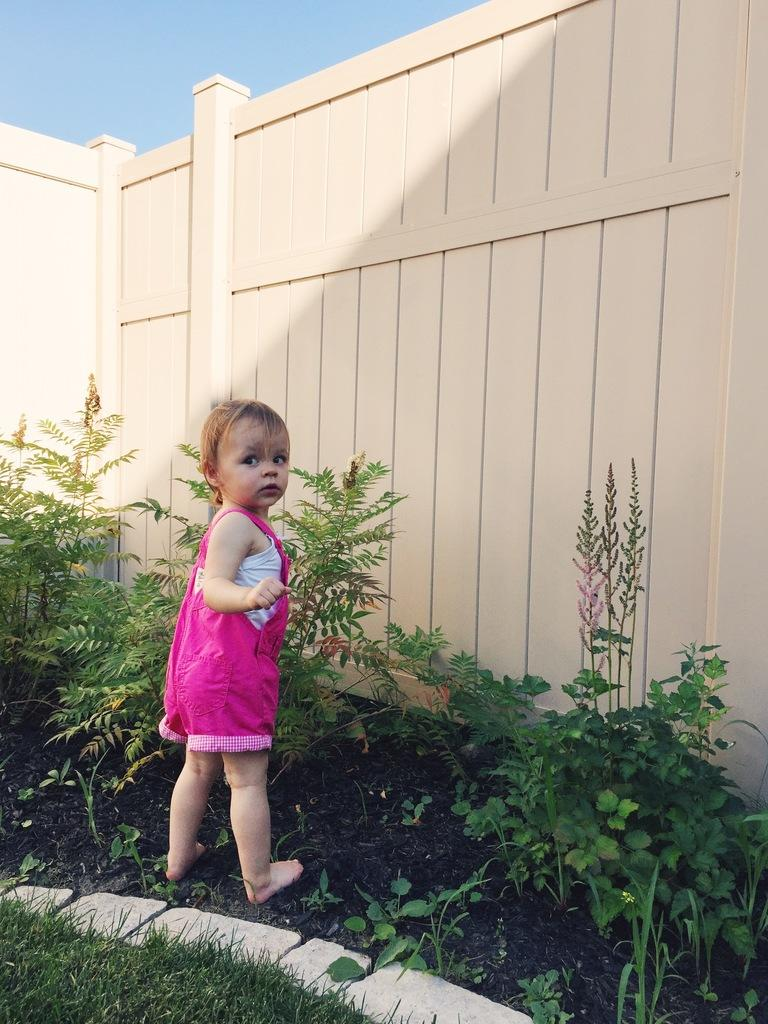What is the main subject of the image? There is a baby in the image. What is the baby wearing? The baby is wearing a pink dress. Where is the baby standing? The baby is standing on grass land. What can be seen in front of the baby? There are plants in front of the baby. What is located behind the plants? There is a fence behind the plants. What is visible above the scene? The sky is visible above the scene. Who is the creator of the button that can be seen in the image? There is no button present in the image, so it is not possible to determine who its creator might be. 